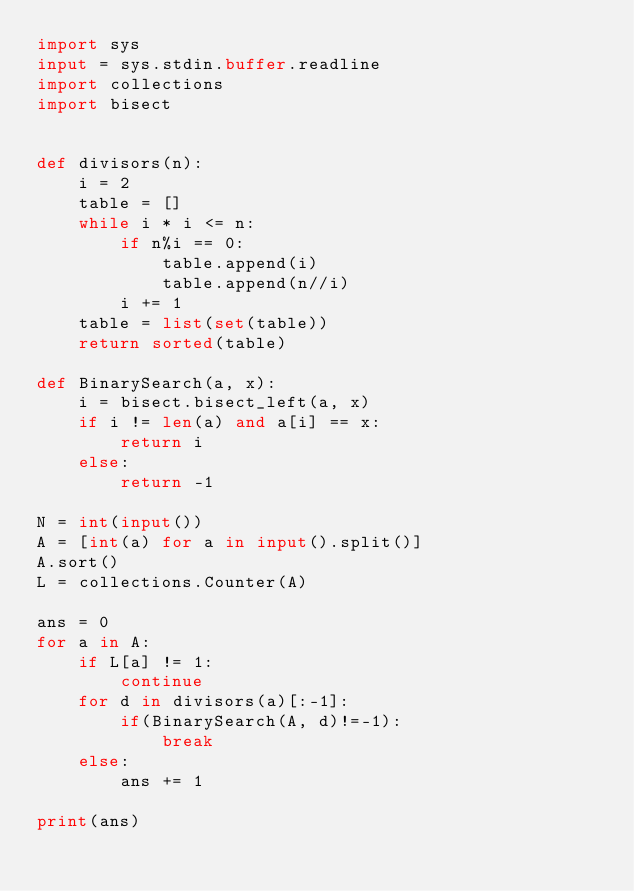<code> <loc_0><loc_0><loc_500><loc_500><_Python_>import sys
input = sys.stdin.buffer.readline
import collections
import bisect


def divisors(n):
    i = 2
    table = []
    while i * i <= n:
        if n%i == 0:
            table.append(i)
            table.append(n//i)
        i += 1
    table = list(set(table))
    return sorted(table)

def BinarySearch(a, x): 
    i = bisect.bisect_left(a, x) 
    if i != len(a) and a[i] == x: 
        return i 
    else: 
        return -1

N = int(input())
A = [int(a) for a in input().split()]
A.sort()
L = collections.Counter(A)

ans = 0
for a in A:
    if L[a] != 1:
        continue
    for d in divisors(a)[:-1]:
        if(BinarySearch(A, d)!=-1):
            break
    else:
        ans += 1

print(ans)</code> 